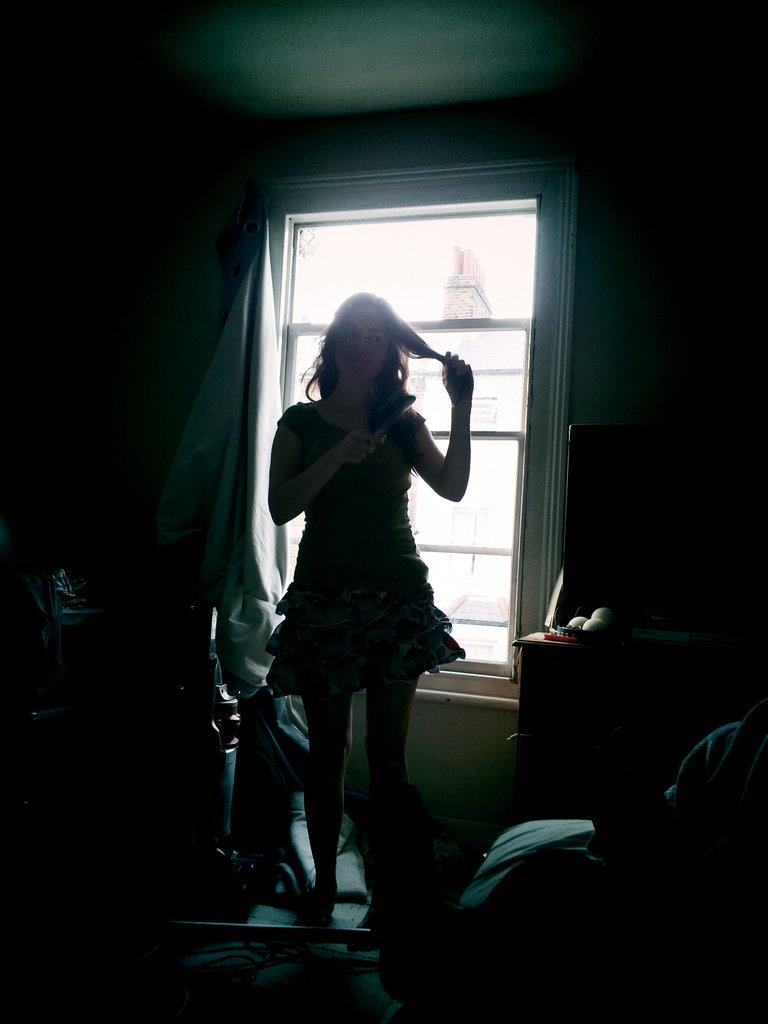Who is the main subject in the image? There is a woman standing in the center of the image. What is the woman standing on? The woman is standing on the floor. What can be seen on the right side of the image? There is a table and a television on the right side of the image. What is visible in the background of the image? There is a window and a curtain associated with the window in the background of the image. What is the number of zephyrs visible in the image? There are no zephyrs present in the image, as zephyrs are a type of gentle breeze and not a visible object. 